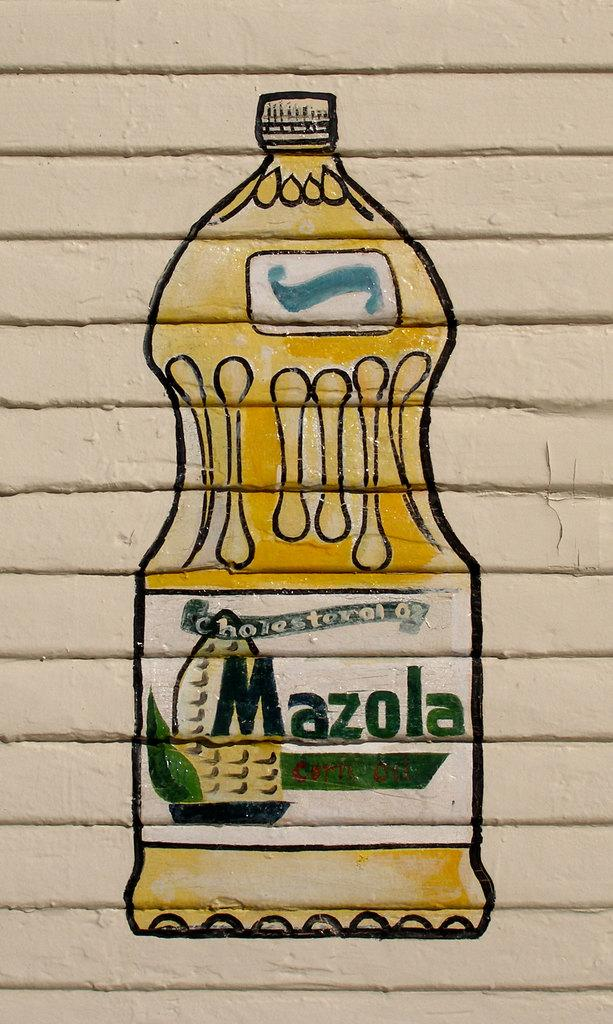Provide a one-sentence caption for the provided image. An artists drawing depicts a bottle of Mazola oil. 